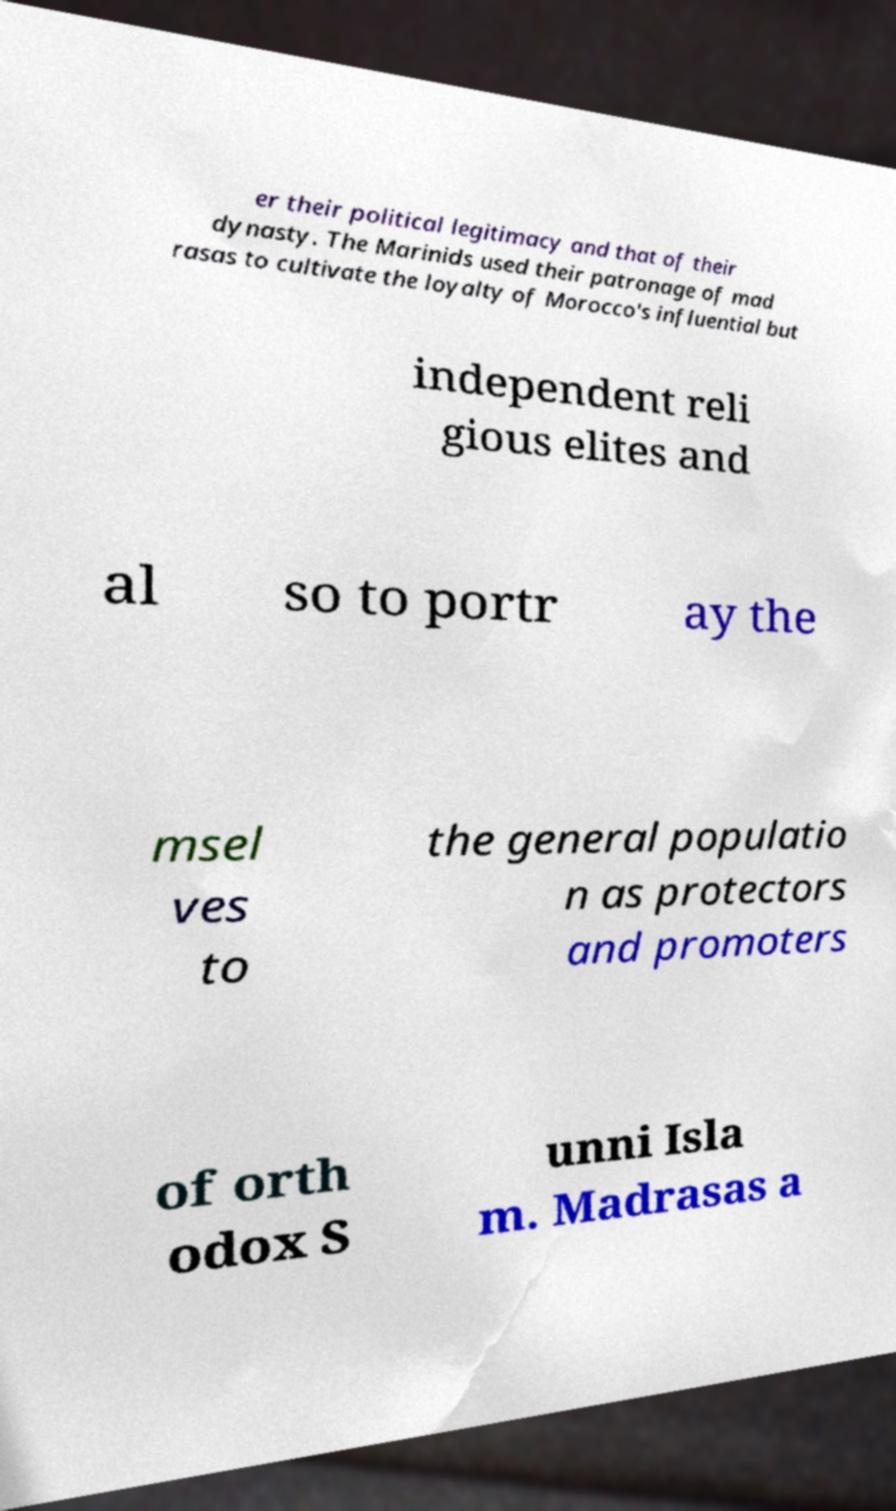What messages or text are displayed in this image? I need them in a readable, typed format. er their political legitimacy and that of their dynasty. The Marinids used their patronage of mad rasas to cultivate the loyalty of Morocco's influential but independent reli gious elites and al so to portr ay the msel ves to the general populatio n as protectors and promoters of orth odox S unni Isla m. Madrasas a 